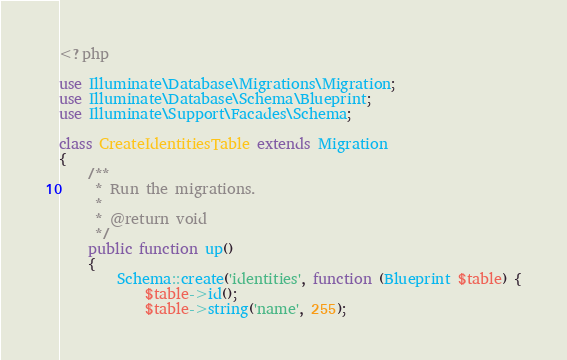<code> <loc_0><loc_0><loc_500><loc_500><_PHP_><?php

use Illuminate\Database\Migrations\Migration;
use Illuminate\Database\Schema\Blueprint;
use Illuminate\Support\Facades\Schema;

class CreateIdentitiesTable extends Migration
{
    /**
     * Run the migrations.
     *
     * @return void
     */
    public function up()
    {
        Schema::create('identities', function (Blueprint $table) {
            $table->id();
            $table->string('name', 255);</code> 